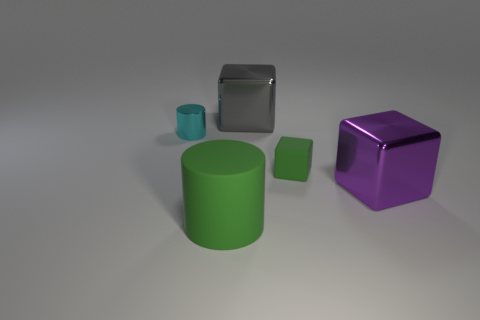Subtract all large blocks. How many blocks are left? 1 Add 1 cyan shiny cylinders. How many objects exist? 6 Subtract all cubes. How many objects are left? 2 Add 3 tiny cubes. How many tiny cubes exist? 4 Subtract 1 gray cubes. How many objects are left? 4 Subtract all purple cubes. Subtract all big purple metal cubes. How many objects are left? 3 Add 4 rubber objects. How many rubber objects are left? 6 